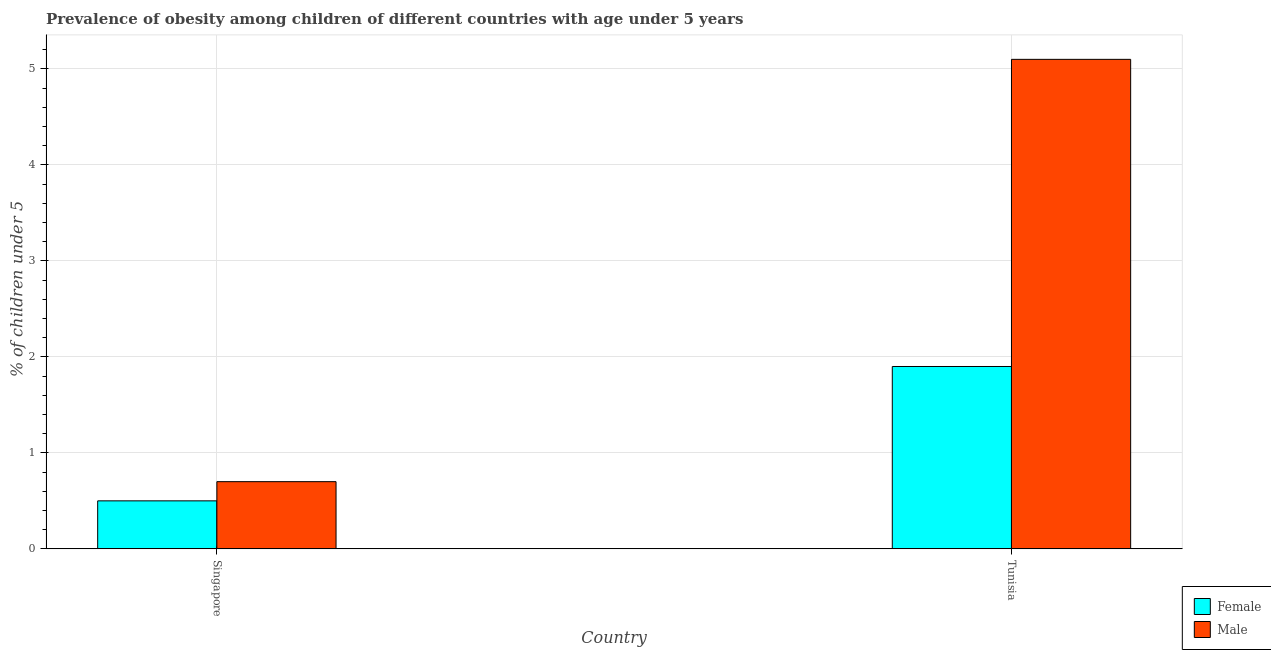Are the number of bars on each tick of the X-axis equal?
Provide a short and direct response. Yes. What is the label of the 2nd group of bars from the left?
Offer a very short reply. Tunisia. In how many cases, is the number of bars for a given country not equal to the number of legend labels?
Provide a succinct answer. 0. What is the percentage of obese female children in Tunisia?
Your answer should be very brief. 1.9. Across all countries, what is the maximum percentage of obese female children?
Your response must be concise. 1.9. Across all countries, what is the minimum percentage of obese male children?
Make the answer very short. 0.7. In which country was the percentage of obese male children maximum?
Offer a very short reply. Tunisia. In which country was the percentage of obese male children minimum?
Provide a succinct answer. Singapore. What is the total percentage of obese female children in the graph?
Your answer should be very brief. 2.4. What is the difference between the percentage of obese female children in Singapore and that in Tunisia?
Your response must be concise. -1.4. What is the difference between the percentage of obese male children in Tunisia and the percentage of obese female children in Singapore?
Offer a terse response. 4.6. What is the average percentage of obese female children per country?
Your answer should be very brief. 1.2. What is the difference between the percentage of obese male children and percentage of obese female children in Tunisia?
Your answer should be compact. 3.2. In how many countries, is the percentage of obese female children greater than 2.4 %?
Keep it short and to the point. 0. What is the ratio of the percentage of obese male children in Singapore to that in Tunisia?
Ensure brevity in your answer.  0.14. In how many countries, is the percentage of obese female children greater than the average percentage of obese female children taken over all countries?
Give a very brief answer. 1. What does the 1st bar from the right in Tunisia represents?
Give a very brief answer. Male. How many bars are there?
Provide a short and direct response. 4. How many countries are there in the graph?
Offer a terse response. 2. What is the difference between two consecutive major ticks on the Y-axis?
Provide a succinct answer. 1. Does the graph contain any zero values?
Ensure brevity in your answer.  No. Does the graph contain grids?
Provide a short and direct response. Yes. Where does the legend appear in the graph?
Your answer should be very brief. Bottom right. How are the legend labels stacked?
Your answer should be compact. Vertical. What is the title of the graph?
Your response must be concise. Prevalence of obesity among children of different countries with age under 5 years. What is the label or title of the X-axis?
Your response must be concise. Country. What is the label or title of the Y-axis?
Your answer should be compact.  % of children under 5. What is the  % of children under 5 in Male in Singapore?
Your answer should be very brief. 0.7. What is the  % of children under 5 of Female in Tunisia?
Your answer should be compact. 1.9. What is the  % of children under 5 in Male in Tunisia?
Your answer should be compact. 5.1. Across all countries, what is the maximum  % of children under 5 of Female?
Offer a very short reply. 1.9. Across all countries, what is the maximum  % of children under 5 in Male?
Provide a succinct answer. 5.1. Across all countries, what is the minimum  % of children under 5 of Male?
Your answer should be compact. 0.7. What is the total  % of children under 5 in Female in the graph?
Provide a short and direct response. 2.4. What is the total  % of children under 5 in Male in the graph?
Ensure brevity in your answer.  5.8. What is the average  % of children under 5 in Male per country?
Provide a succinct answer. 2.9. What is the difference between the  % of children under 5 of Female and  % of children under 5 of Male in Tunisia?
Your response must be concise. -3.2. What is the ratio of the  % of children under 5 of Female in Singapore to that in Tunisia?
Give a very brief answer. 0.26. What is the ratio of the  % of children under 5 of Male in Singapore to that in Tunisia?
Offer a terse response. 0.14. What is the difference between the highest and the second highest  % of children under 5 in Male?
Offer a very short reply. 4.4. What is the difference between the highest and the lowest  % of children under 5 in Male?
Keep it short and to the point. 4.4. 